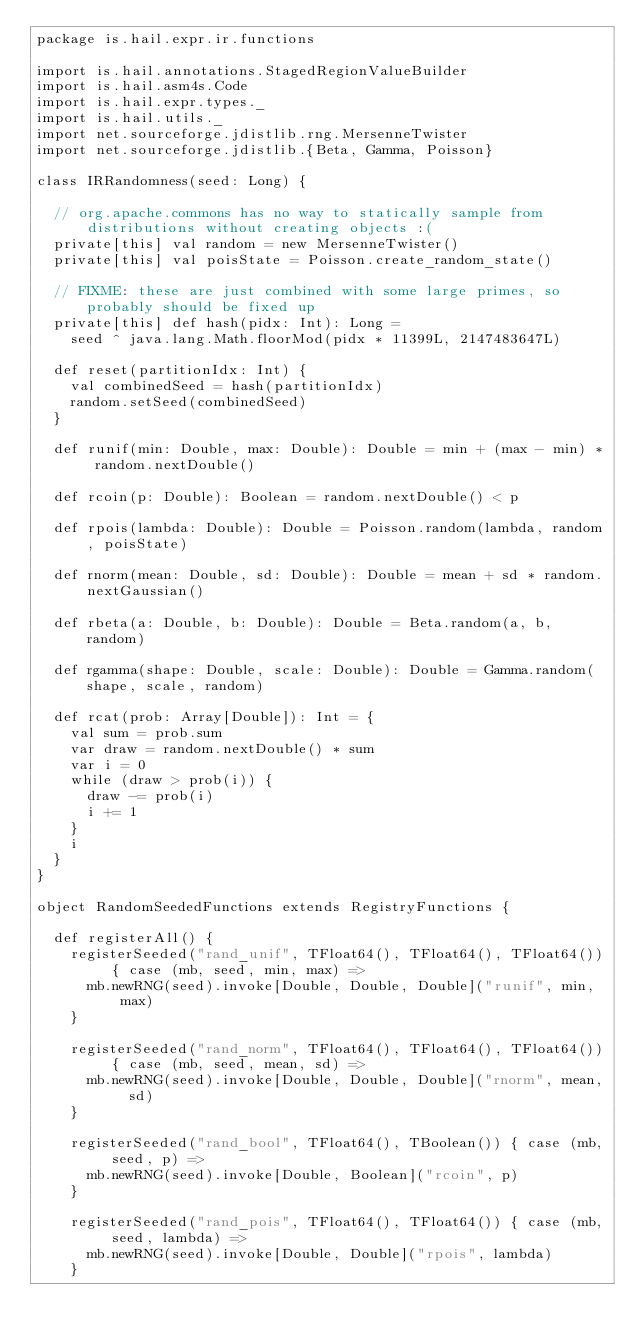<code> <loc_0><loc_0><loc_500><loc_500><_Scala_>package is.hail.expr.ir.functions

import is.hail.annotations.StagedRegionValueBuilder
import is.hail.asm4s.Code
import is.hail.expr.types._
import is.hail.utils._
import net.sourceforge.jdistlib.rng.MersenneTwister
import net.sourceforge.jdistlib.{Beta, Gamma, Poisson}

class IRRandomness(seed: Long) {

  // org.apache.commons has no way to statically sample from distributions without creating objects :(
  private[this] val random = new MersenneTwister()
  private[this] val poisState = Poisson.create_random_state()

  // FIXME: these are just combined with some large primes, so probably should be fixed up
  private[this] def hash(pidx: Int): Long =
    seed ^ java.lang.Math.floorMod(pidx * 11399L, 2147483647L)

  def reset(partitionIdx: Int) {
    val combinedSeed = hash(partitionIdx)
    random.setSeed(combinedSeed)
  }

  def runif(min: Double, max: Double): Double = min + (max - min) * random.nextDouble()

  def rcoin(p: Double): Boolean = random.nextDouble() < p

  def rpois(lambda: Double): Double = Poisson.random(lambda, random, poisState)

  def rnorm(mean: Double, sd: Double): Double = mean + sd * random.nextGaussian()

  def rbeta(a: Double, b: Double): Double = Beta.random(a, b, random)

  def rgamma(shape: Double, scale: Double): Double = Gamma.random(shape, scale, random)

  def rcat(prob: Array[Double]): Int = {
    val sum = prob.sum
    var draw = random.nextDouble() * sum
    var i = 0
    while (draw > prob(i)) {
      draw -= prob(i)
      i += 1
    }
    i
  }
}

object RandomSeededFunctions extends RegistryFunctions {

  def registerAll() {
    registerSeeded("rand_unif", TFloat64(), TFloat64(), TFloat64()) { case (mb, seed, min, max) =>
      mb.newRNG(seed).invoke[Double, Double, Double]("runif", min, max)
    }

    registerSeeded("rand_norm", TFloat64(), TFloat64(), TFloat64()) { case (mb, seed, mean, sd) =>
      mb.newRNG(seed).invoke[Double, Double, Double]("rnorm", mean, sd)
    }

    registerSeeded("rand_bool", TFloat64(), TBoolean()) { case (mb, seed, p) =>
      mb.newRNG(seed).invoke[Double, Boolean]("rcoin", p)
    }

    registerSeeded("rand_pois", TFloat64(), TFloat64()) { case (mb, seed, lambda) =>
      mb.newRNG(seed).invoke[Double, Double]("rpois", lambda)
    }
</code> 